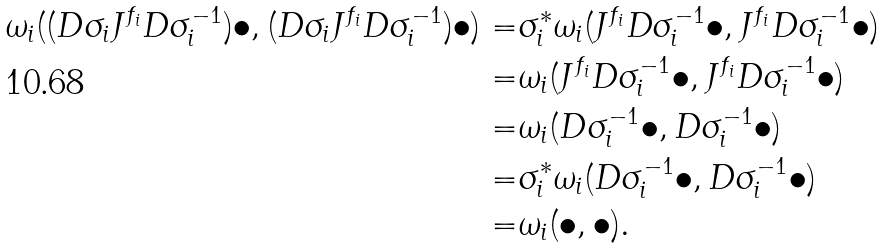Convert formula to latex. <formula><loc_0><loc_0><loc_500><loc_500>\omega _ { i } ( ( D \sigma _ { i } J ^ { f _ { i } } D \sigma _ { i } ^ { - 1 } ) \bullet , ( D \sigma _ { i } J ^ { f _ { i } } D \sigma _ { i } ^ { - 1 } ) \bullet ) = & \sigma _ { i } ^ { * } \omega _ { i } ( J ^ { f _ { i } } D \sigma _ { i } ^ { - 1 } \bullet , J ^ { f _ { i } } D \sigma _ { i } ^ { - 1 } \bullet ) \\ = & \omega _ { i } ( J ^ { f _ { i } } D \sigma _ { i } ^ { - 1 } \bullet , J ^ { f _ { i } } D \sigma _ { i } ^ { - 1 } \bullet ) \\ = & \omega _ { i } ( D \sigma _ { i } ^ { - 1 } \bullet , D \sigma _ { i } ^ { - 1 } \bullet ) \\ = & \sigma _ { i } ^ { * } \omega _ { i } ( D \sigma _ { i } ^ { - 1 } \bullet , D \sigma _ { i } ^ { - 1 } \bullet ) \\ = & \omega _ { i } ( \bullet , \bullet ) .</formula> 